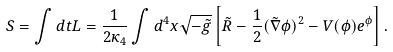<formula> <loc_0><loc_0><loc_500><loc_500>S = \int d t L = \frac { 1 } { 2 \kappa _ { 4 } } \int d ^ { 4 } x \sqrt { - \tilde { g } } \left [ \tilde { R } - \frac { 1 } { 2 } ( \tilde { \nabla } \phi ) ^ { 2 } - V ( \phi ) e ^ { \phi } \right ] .</formula> 